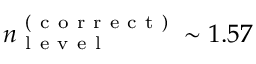Convert formula to latex. <formula><loc_0><loc_0><loc_500><loc_500>n _ { l e v e l } ^ { ( c o r r e c t ) } \sim 1 . 5 7</formula> 